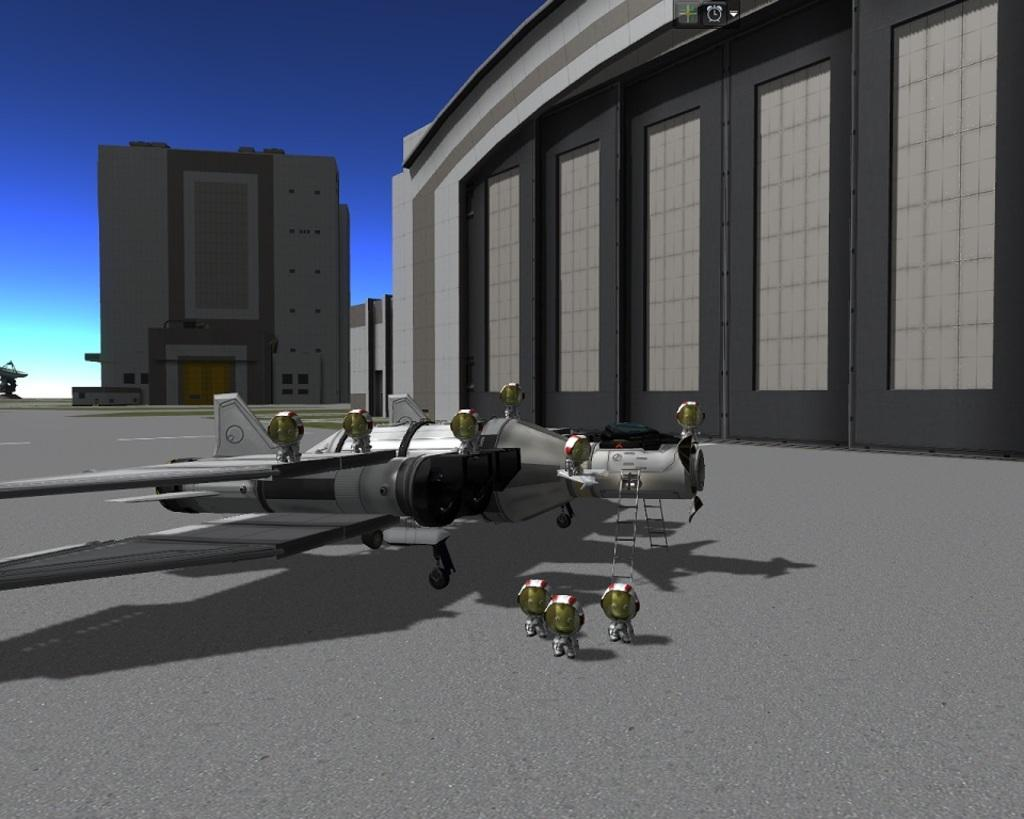What type of image is being described? The image is animated. What can be seen on the ground in the image? There is a machine on the ground in the image. What is visible in the background of the image? There are buildings in the background of the image. What is visible at the top of the image? The sky is visible at the top of the image. What type of insurance is being advertised on the machine in the image? There is no insurance being advertised on the machine in the image. What type of business is associated with the machine in the image? The image does not provide information about any associated business. Can you see a cracker in the image? There is no cracker present in the image. 